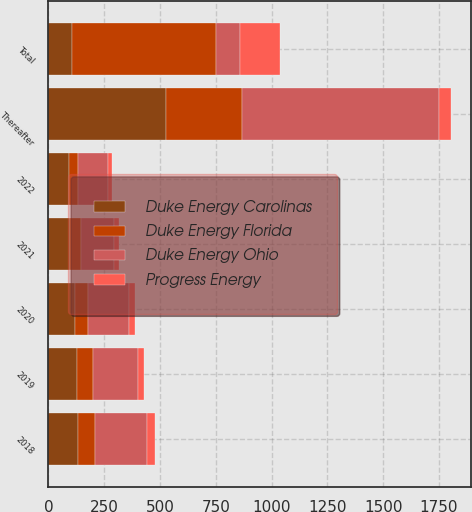Convert chart. <chart><loc_0><loc_0><loc_500><loc_500><stacked_bar_chart><ecel><fcel>2018<fcel>2019<fcel>2020<fcel>2021<fcel>2022<fcel>Thereafter<fcel>Total<nl><fcel>Duke Energy Ohio<fcel>233<fcel>203<fcel>183<fcel>150<fcel>135<fcel>882<fcel>107<nl><fcel>Progress Energy<fcel>36<fcel>29<fcel>25<fcel>19<fcel>16<fcel>52<fcel>177<nl><fcel>Duke Energy Carolinas<fcel>133<fcel>126<fcel>117<fcel>97<fcel>90<fcel>525<fcel>107<nl><fcel>Duke Energy Florida<fcel>77<fcel>72<fcel>62<fcel>48<fcel>42<fcel>344<fcel>645<nl></chart> 